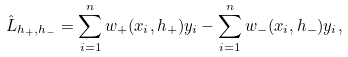Convert formula to latex. <formula><loc_0><loc_0><loc_500><loc_500>\hat { L } _ { h _ { + } , h _ { - } } = \sum _ { i = 1 } ^ { n } w _ { + } ( x _ { i } , h _ { + } ) y _ { i } - \sum _ { i = 1 } ^ { n } w _ { - } ( x _ { i } , h _ { - } ) y _ { i } ,</formula> 